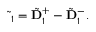<formula> <loc_0><loc_0><loc_500><loc_500>\begin{array} { r } { \tilde { \Delta } _ { 1 } = \tilde { D } _ { 1 } ^ { + } - \tilde { D } _ { 1 } ^ { - } . } \end{array}</formula> 